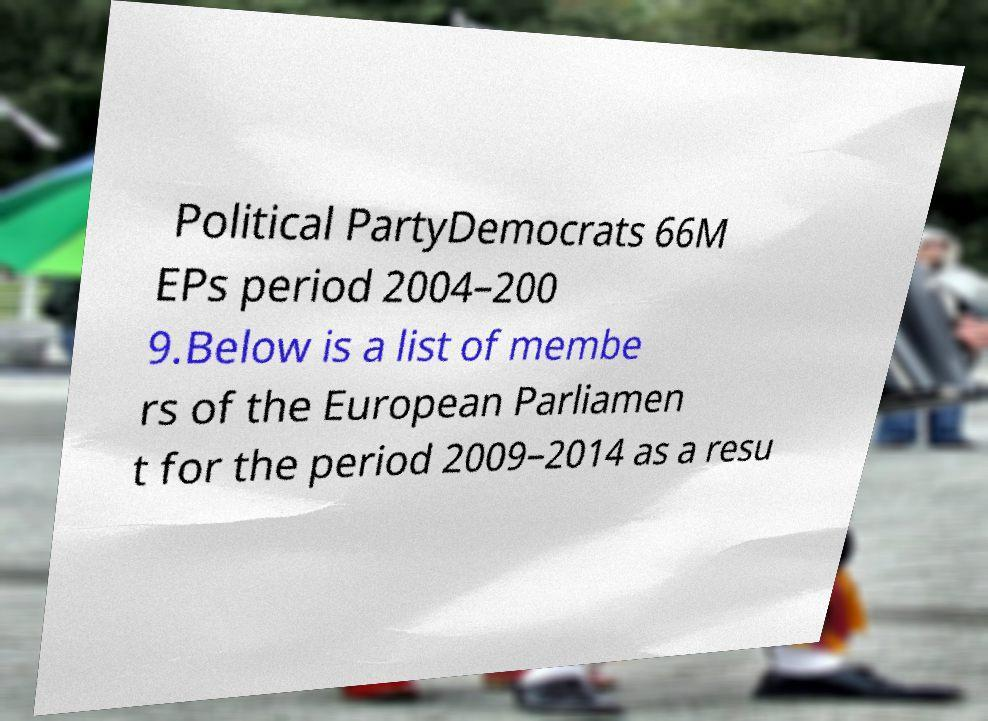Please identify and transcribe the text found in this image. Political PartyDemocrats 66M EPs period 2004–200 9.Below is a list of membe rs of the European Parliamen t for the period 2009–2014 as a resu 